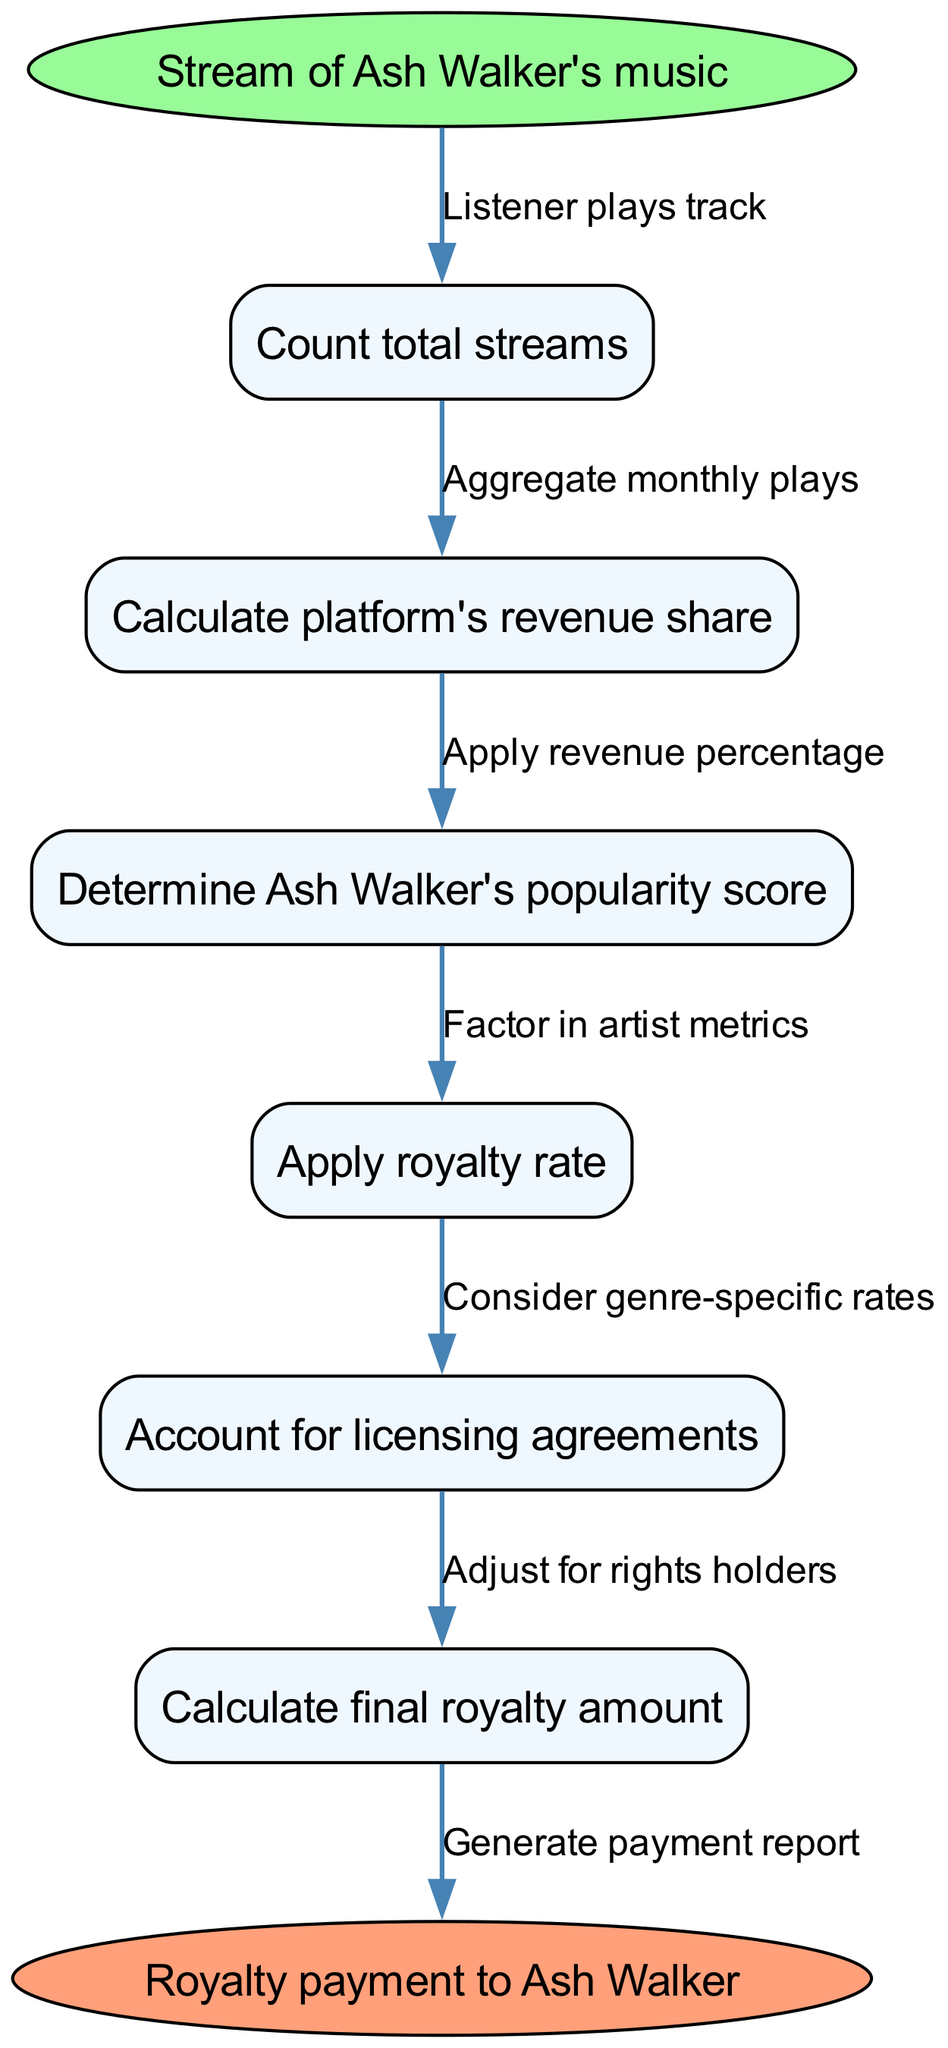What is the starting point of the diagram? The starting point of the diagram is indicated by the "Stream of Ash Walker's music" node, which signifies the initiation of the royalty calculation process.
Answer: Stream of Ash Walker's music How many nodes are in the diagram? The diagram contains six intermediate nodes in addition to the start and end nodes, making a total of eight nodes.
Answer: Eight What is the end point of the diagram? The end point of the diagram is represented by the "Royalty payment to Ash Walker" node, which signifies the conclusion of the royalty calculation process.
Answer: Royalty payment to Ash Walker Which node comes after "Count total streams"? The node that follows "Count total streams" is "Calculate platform's revenue share," indicating the next step in the flow of royalties.
Answer: Calculate platform's revenue share How does the process start? The process begins when a listener plays Ash Walker's track, which triggers the subsequent calculations leading to royalties.
Answer: Listener plays track What is the last step before the royalty payment? The last step before the royalty payment is "Calculate final royalty amount," which indicates the computation of the exact payment to be made.
Answer: Calculate final royalty amount What is considered in the royalty calculation? The calculation takes into account "licensing agreements," which implicates any legalities surrounding the distribution of Ash Walker's music.
Answer: Licensing agreements How many edges are present in the diagram? There are seven edges in the diagram since each connection or relationship between nodes constitutes an edge.
Answer: Seven What must be adjusted for before the final payment? Before the final payment, the diagram shows that adjustments must be made for "rights holders," which ensures that all entitled parties receive their due shares.
Answer: Rights holders 